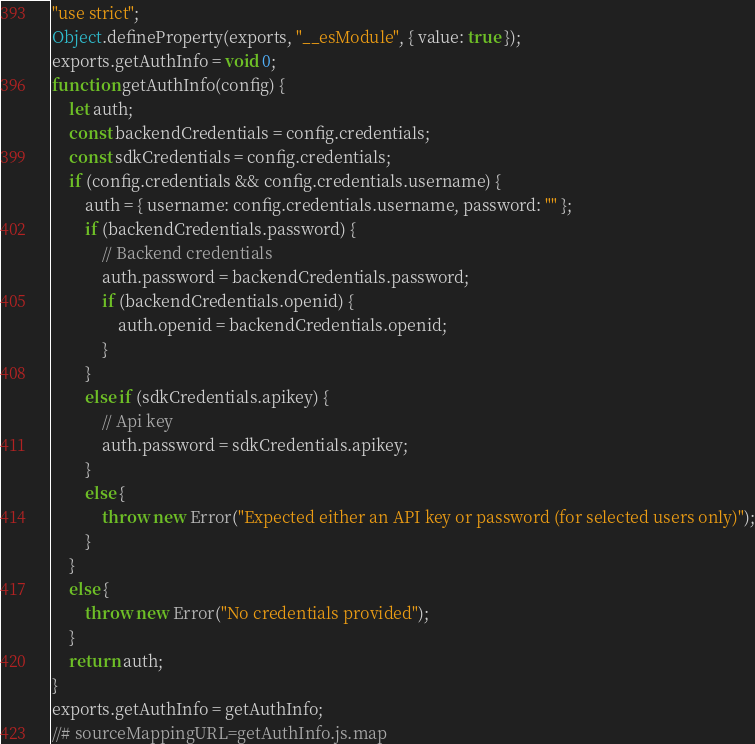<code> <loc_0><loc_0><loc_500><loc_500><_JavaScript_>"use strict";
Object.defineProperty(exports, "__esModule", { value: true });
exports.getAuthInfo = void 0;
function getAuthInfo(config) {
    let auth;
    const backendCredentials = config.credentials;
    const sdkCredentials = config.credentials;
    if (config.credentials && config.credentials.username) {
        auth = { username: config.credentials.username, password: "" };
        if (backendCredentials.password) {
            // Backend credentials
            auth.password = backendCredentials.password;
            if (backendCredentials.openid) {
                auth.openid = backendCredentials.openid;
            }
        }
        else if (sdkCredentials.apikey) {
            // Api key
            auth.password = sdkCredentials.apikey;
        }
        else {
            throw new Error("Expected either an API key or password (for selected users only)");
        }
    }
    else {
        throw new Error("No credentials provided");
    }
    return auth;
}
exports.getAuthInfo = getAuthInfo;
//# sourceMappingURL=getAuthInfo.js.map</code> 